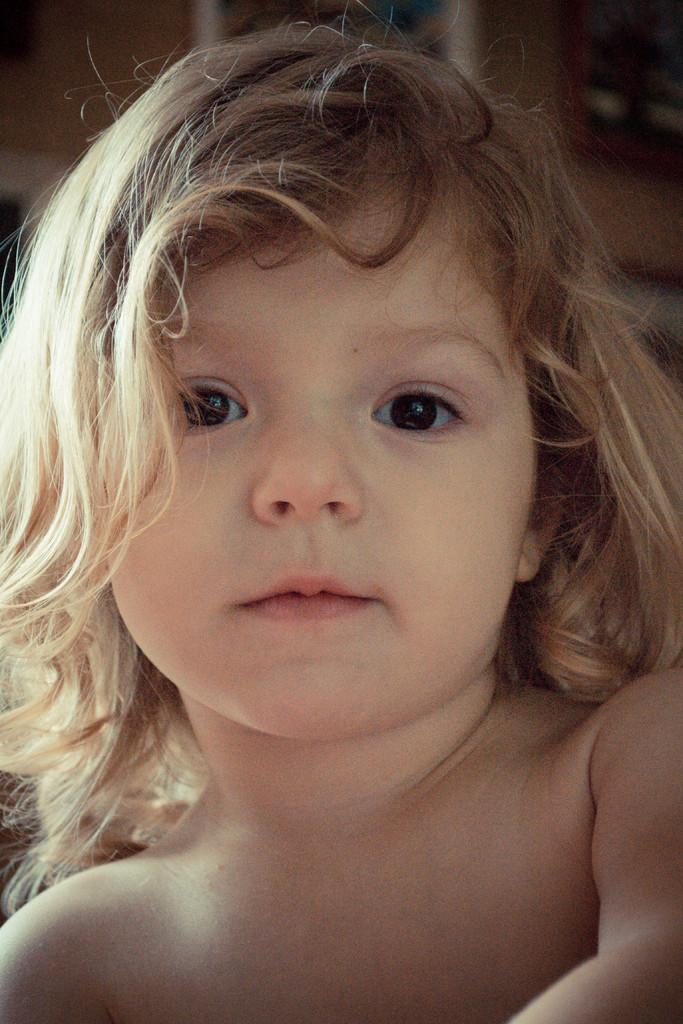Who is the main subject in the image? There is a girl in the image. What is the girl doing in the image? The girl is smiling. Can you describe the background of the image? The background of the image is blurry. What type of drug is the girl attempting to hide in the image? There is no drug present in the image, and the girl is not attempting to hide anything. 